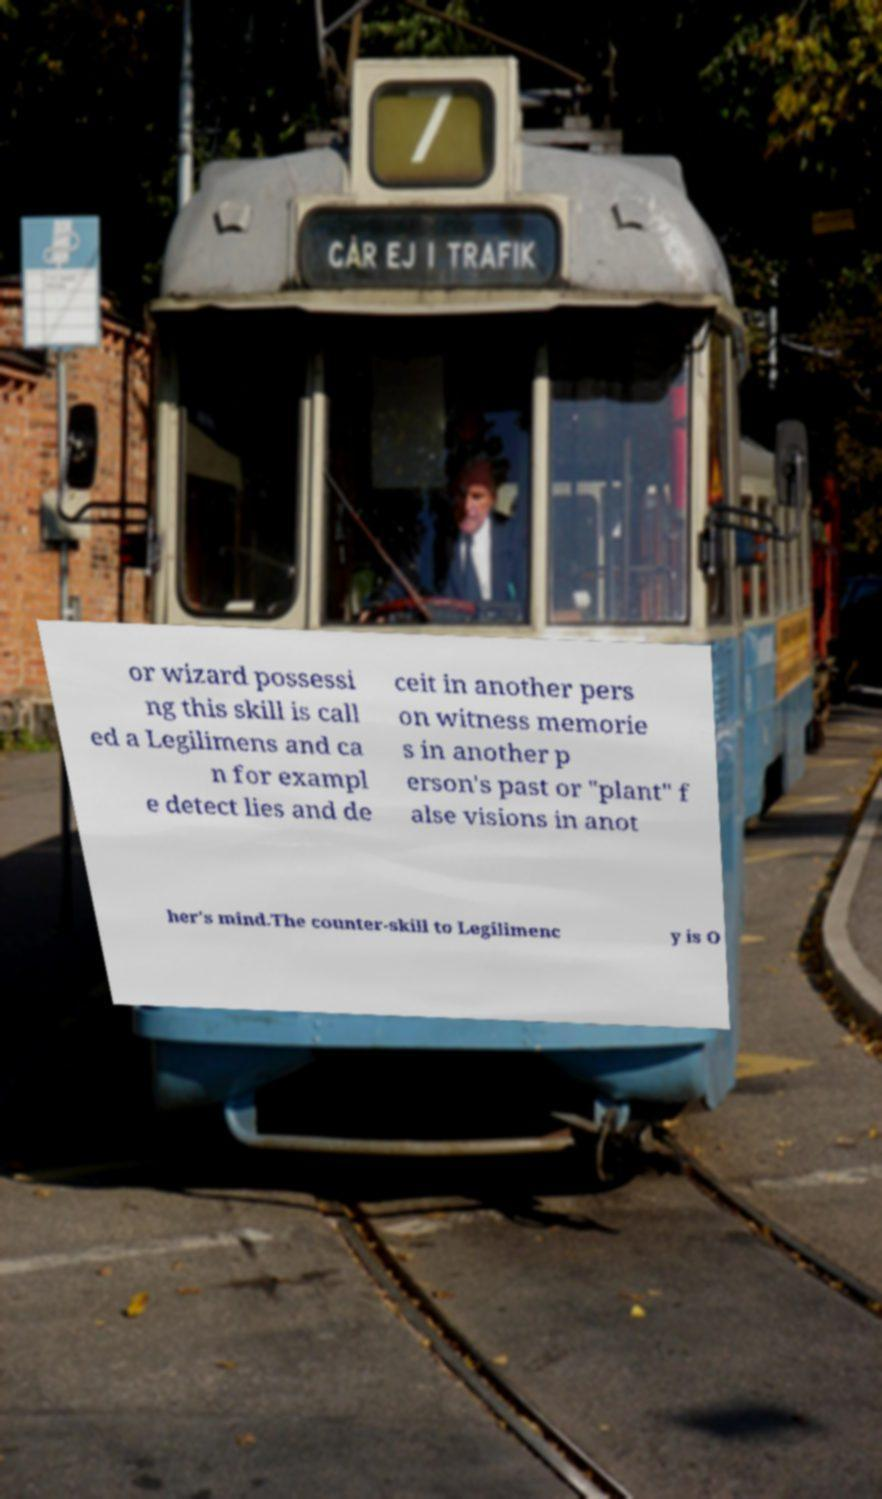What messages or text are displayed in this image? I need them in a readable, typed format. or wizard possessi ng this skill is call ed a Legilimens and ca n for exampl e detect lies and de ceit in another pers on witness memorie s in another p erson's past or "plant" f alse visions in anot her's mind.The counter-skill to Legilimenc y is O 